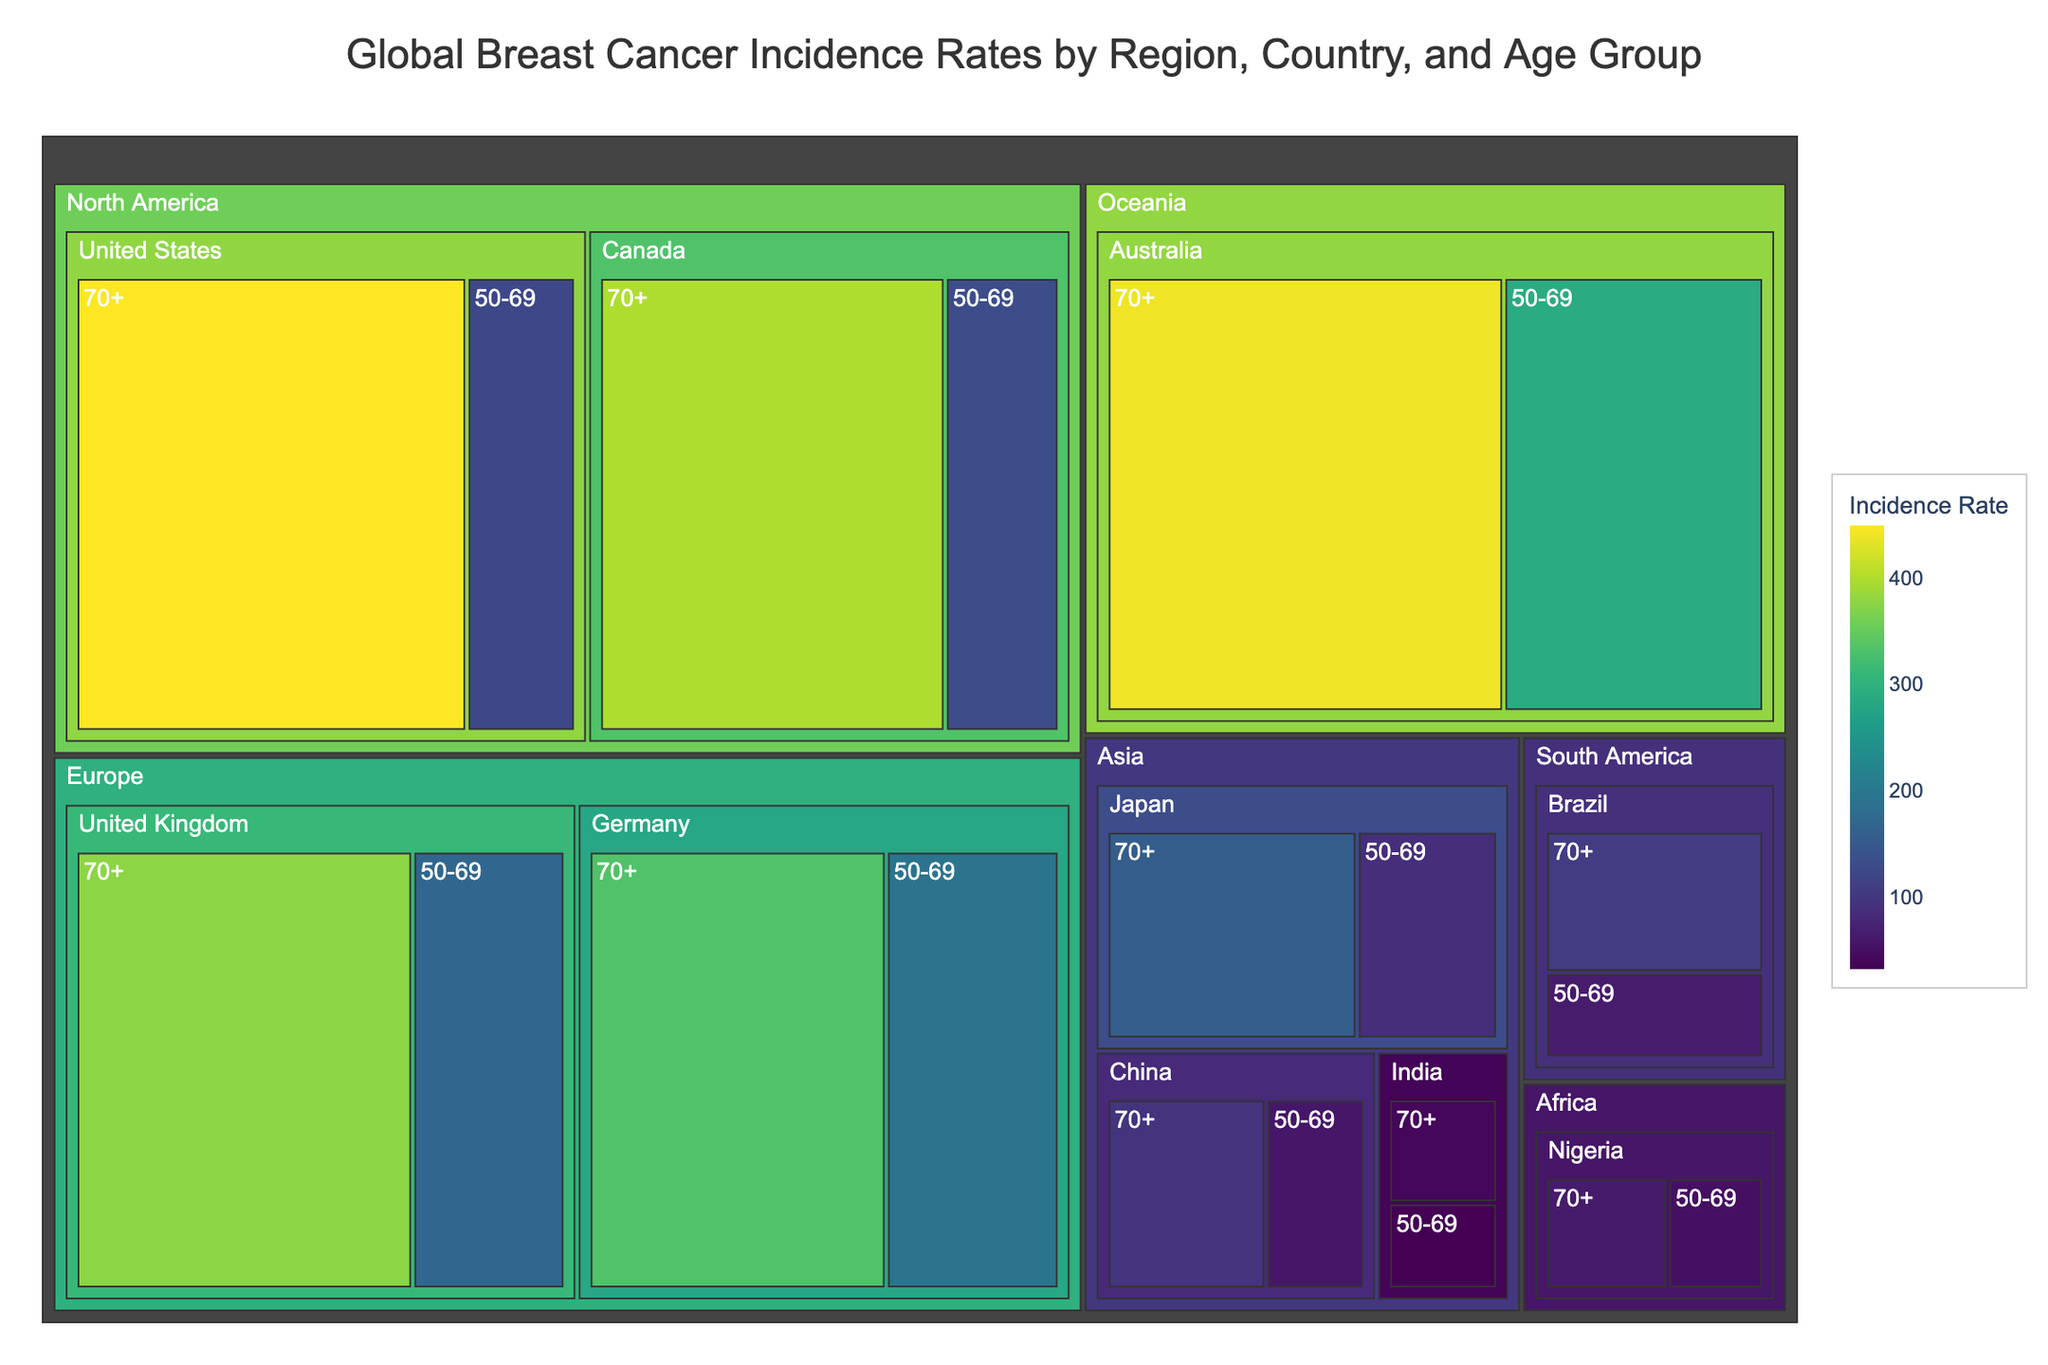What region has the highest incidence rate for the 70+ age group? To determine the region with the highest incidence rate for the 70+ age group, look for the boxes within the figure that represent the 70+ age category. The box with the highest value and its corresponding region will give you the answer.
Answer: North America Which country in Europe has a higher incidence rate for the 50-69 age group? Look at the boxes under the Europe region for the age group 50-69 and compare the incidence rates of the countries within Europe. The country with the higher value will be your answer.
Answer: Germany How does the incidence rate of breast cancer in Australia for the 70+ age group compare with Canada for the same age group? Find and compare the values for Australia and Canada in the 70+ age group. The shades of the colors and the numerical values will tell the comparison.
Answer: Australia is slightly higher Which region has the lowest incidence rate for the 50-69 age group? Examine the color shades or values under each region for the 50-69 age group. The region with the lightest color shade (or lowest value) will be the one with the lowest incidence rate.
Answer: Asia What is the average incidence rate for the 50-69 age group in North America? To find the average, add the incidence rates of countries in North America for the 50-69 age group and divide by the number of countries. The values are 124.9 (United States) and 131.5 (Canada), so the average is (124.9 + 131.5) / 2 = 128.2.
Answer: 128.2 Which country has the highest incidence rate for the 50-69 age group in Asia? Check the incidence rates for each country in Asia for the 50-69 age group. The highest value will indicate the country.
Answer: Japan Compare the incidence rate for the United States and Germany for the 70+ age group. Identify the incidence rates for the United States and Germany in the 70+ age group and compare the two numbers. United States has 449.1 and Germany has 332.9.
Answer: United States What demographic factor seems to most influence higher incidence rates in the figure? Observe the patterns across the demographic factors (Region, Country, Age Group). Notice that higher incidence rates are often associated with the 70+ age group across different countries.
Answer: Age Group (70+) What is the sum of incidence rates for the 50-69 age group in Europe? Add the incidence rate values for the European countries in the 50-69 age group. The values are 170.3 (United Kingdom) and 193.7 (Germany), so the sum is 170.3 + 193.7 = 364.
Answer: 364 